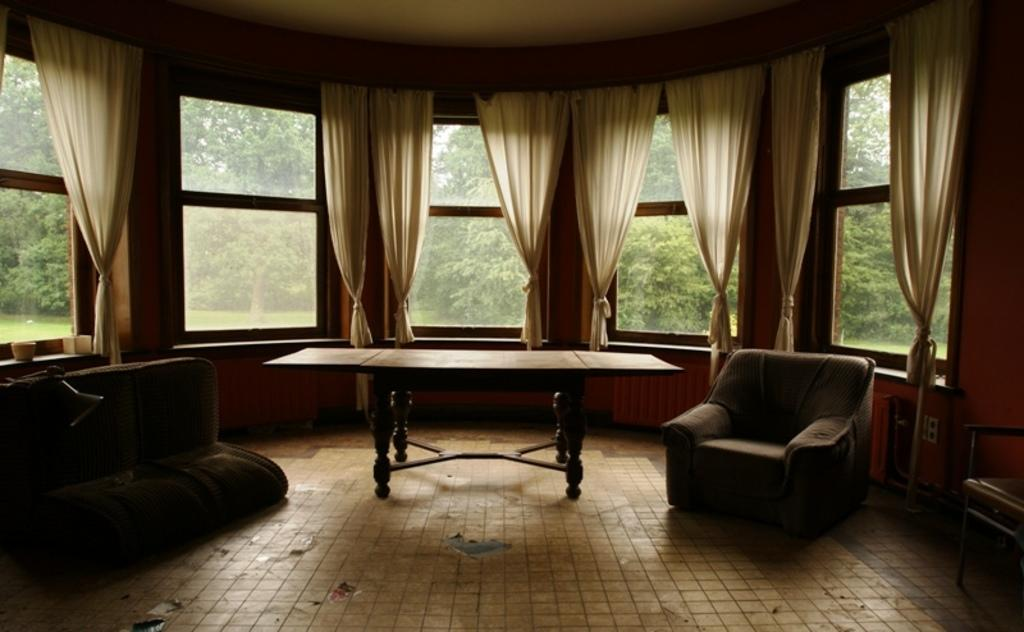What type of space is shown in the image? The image depicts a room. What furniture is present in the room? There is a sofa, a chair, and a table in the room. What type of window treatment is present in the room? There are curtains in the room. What can be seen through the window in the room? Trees are visible in the background through the window. What type of stick can be seen in the image? There is no stick present in the image. Are there any berries visible on the trees in the background? The image does not show any berries on the trees; only the trees themselves are visible. 